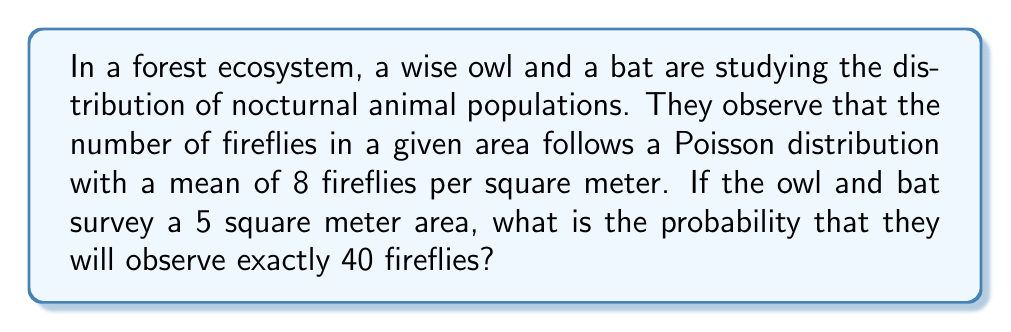Teach me how to tackle this problem. Let's approach this step-by-step:

1) The number of fireflies follows a Poisson distribution with a mean of 8 per square meter.

2) We are surveying a 5 square meter area, so the mean for this larger area is:
   $\lambda = 8 \times 5 = 40$ fireflies

3) The probability mass function for a Poisson distribution is:

   $$P(X = k) = \frac{e^{-\lambda}\lambda^k}{k!}$$

   where $\lambda$ is the mean and $k$ is the number of occurrences.

4) In this case, we want $P(X = 40)$ with $\lambda = 40$:

   $$P(X = 40) = \frac{e^{-40}40^{40}}{40!}$$

5) Let's calculate this step-by-step:
   
   a) $e^{-40} \approx 4.2481 \times 10^{-18}$
   b) $40^{40} \approx 1.2089 \times 10^{64}$
   c) $40! \approx 8.1592 \times 10^{47}$

6) Putting it all together:

   $$P(X = 40) = \frac{4.2481 \times 10^{-18} \times 1.2089 \times 10^{64}}{8.1592 \times 10^{47}} \approx 0.0626$$

Therefore, the probability of observing exactly 40 fireflies in the 5 square meter area is approximately 0.0626 or 6.26%.
Answer: 0.0626 